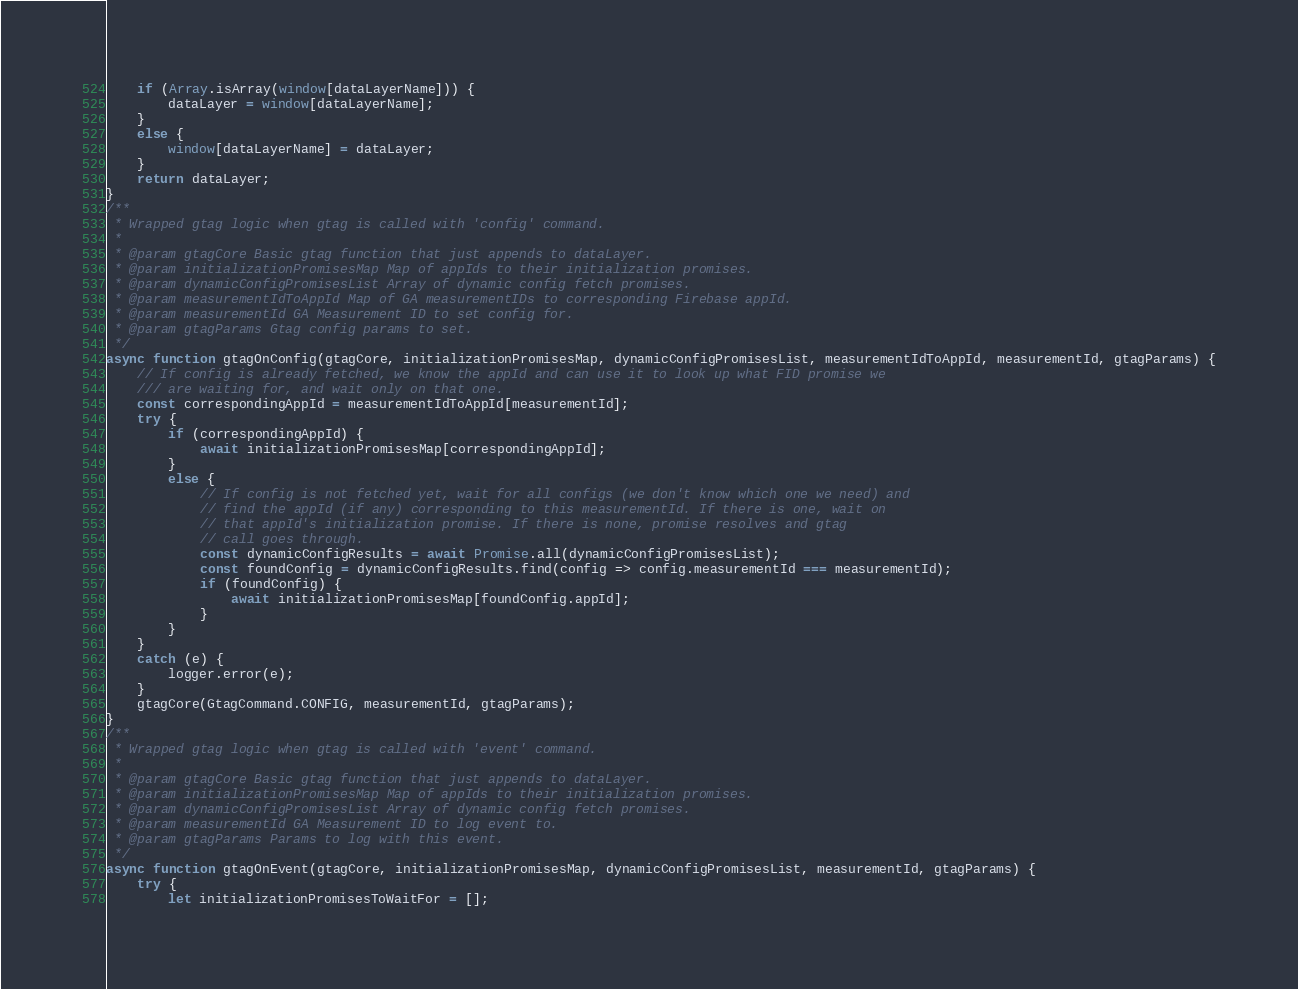Convert code to text. <code><loc_0><loc_0><loc_500><loc_500><_JavaScript_>    if (Array.isArray(window[dataLayerName])) {
        dataLayer = window[dataLayerName];
    }
    else {
        window[dataLayerName] = dataLayer;
    }
    return dataLayer;
}
/**
 * Wrapped gtag logic when gtag is called with 'config' command.
 *
 * @param gtagCore Basic gtag function that just appends to dataLayer.
 * @param initializationPromisesMap Map of appIds to their initialization promises.
 * @param dynamicConfigPromisesList Array of dynamic config fetch promises.
 * @param measurementIdToAppId Map of GA measurementIDs to corresponding Firebase appId.
 * @param measurementId GA Measurement ID to set config for.
 * @param gtagParams Gtag config params to set.
 */
async function gtagOnConfig(gtagCore, initializationPromisesMap, dynamicConfigPromisesList, measurementIdToAppId, measurementId, gtagParams) {
    // If config is already fetched, we know the appId and can use it to look up what FID promise we
    /// are waiting for, and wait only on that one.
    const correspondingAppId = measurementIdToAppId[measurementId];
    try {
        if (correspondingAppId) {
            await initializationPromisesMap[correspondingAppId];
        }
        else {
            // If config is not fetched yet, wait for all configs (we don't know which one we need) and
            // find the appId (if any) corresponding to this measurementId. If there is one, wait on
            // that appId's initialization promise. If there is none, promise resolves and gtag
            // call goes through.
            const dynamicConfigResults = await Promise.all(dynamicConfigPromisesList);
            const foundConfig = dynamicConfigResults.find(config => config.measurementId === measurementId);
            if (foundConfig) {
                await initializationPromisesMap[foundConfig.appId];
            }
        }
    }
    catch (e) {
        logger.error(e);
    }
    gtagCore(GtagCommand.CONFIG, measurementId, gtagParams);
}
/**
 * Wrapped gtag logic when gtag is called with 'event' command.
 *
 * @param gtagCore Basic gtag function that just appends to dataLayer.
 * @param initializationPromisesMap Map of appIds to their initialization promises.
 * @param dynamicConfigPromisesList Array of dynamic config fetch promises.
 * @param measurementId GA Measurement ID to log event to.
 * @param gtagParams Params to log with this event.
 */
async function gtagOnEvent(gtagCore, initializationPromisesMap, dynamicConfigPromisesList, measurementId, gtagParams) {
    try {
        let initializationPromisesToWaitFor = [];</code> 